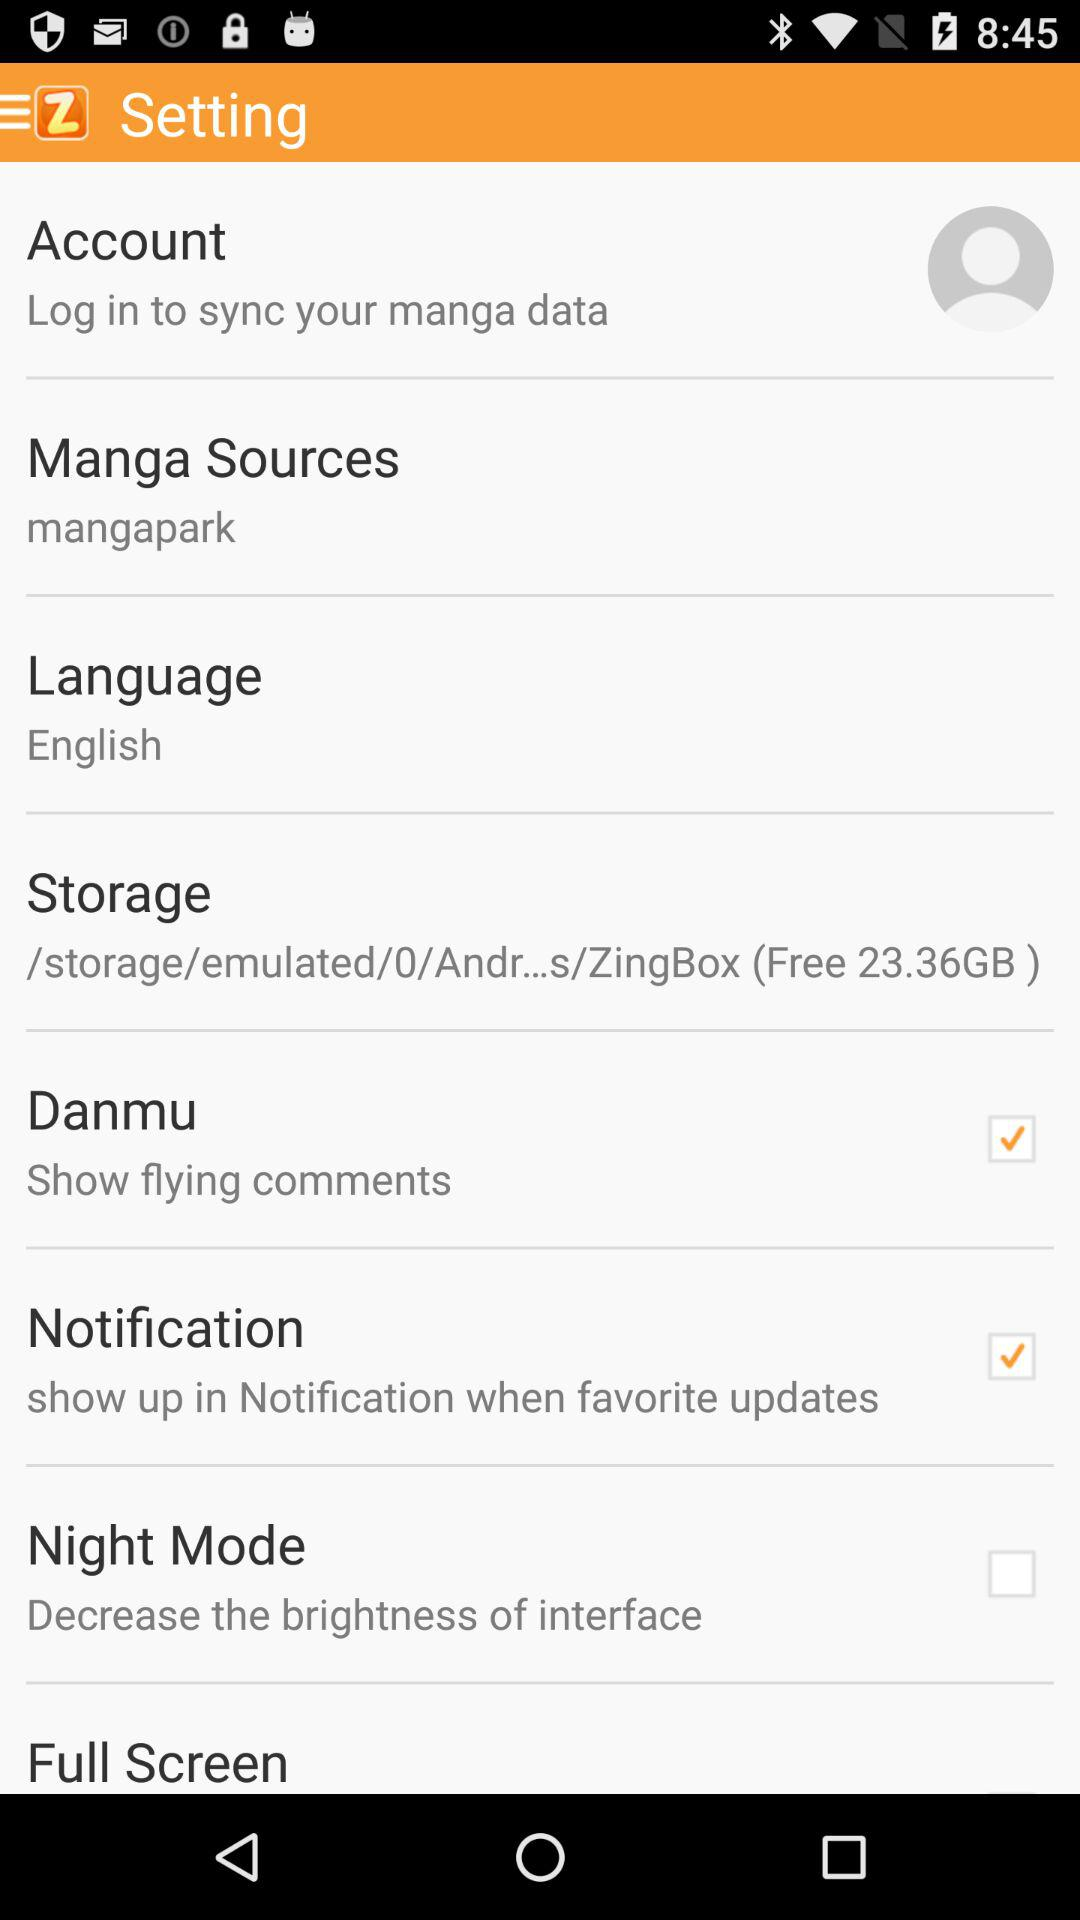How many checkboxes are in the settings menu?
Answer the question using a single word or phrase. 3 